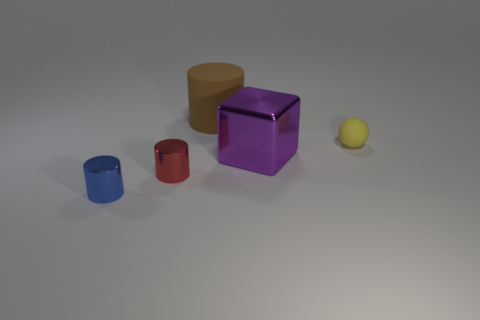Subtract all blue metallic cylinders. How many cylinders are left? 2 Add 1 large brown objects. How many objects exist? 6 Subtract all balls. How many objects are left? 4 Subtract 1 balls. How many balls are left? 0 Add 2 small blue rubber cubes. How many small blue rubber cubes exist? 2 Subtract 0 yellow cylinders. How many objects are left? 5 Subtract all green cylinders. Subtract all gray spheres. How many cylinders are left? 3 Subtract all tiny red things. Subtract all metallic cubes. How many objects are left? 3 Add 5 brown cylinders. How many brown cylinders are left? 6 